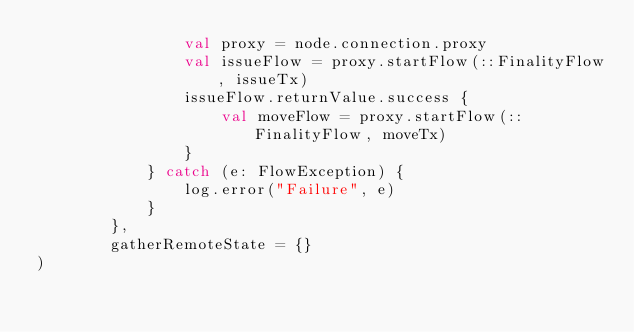Convert code to text. <code><loc_0><loc_0><loc_500><loc_500><_Kotlin_>                val proxy = node.connection.proxy
                val issueFlow = proxy.startFlow(::FinalityFlow, issueTx)
                issueFlow.returnValue.success {
                    val moveFlow = proxy.startFlow(::FinalityFlow, moveTx)
                }
            } catch (e: FlowException) {
                log.error("Failure", e)
            }
        },
        gatherRemoteState = {}
)
</code> 